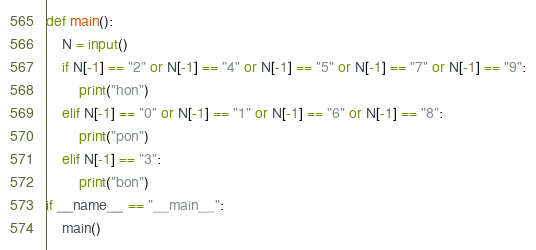Convert code to text. <code><loc_0><loc_0><loc_500><loc_500><_Python_>def main():
    N = input()
    if N[-1] == "2" or N[-1] == "4" or N[-1] == "5" or N[-1] == "7" or N[-1] == "9":
        print("hon")
    elif N[-1] == "0" or N[-1] == "1" or N[-1] == "6" or N[-1] == "8":
        print("pon")
    elif N[-1] == "3":
        print("bon")
if __name__ == "__main__":
    main()</code> 